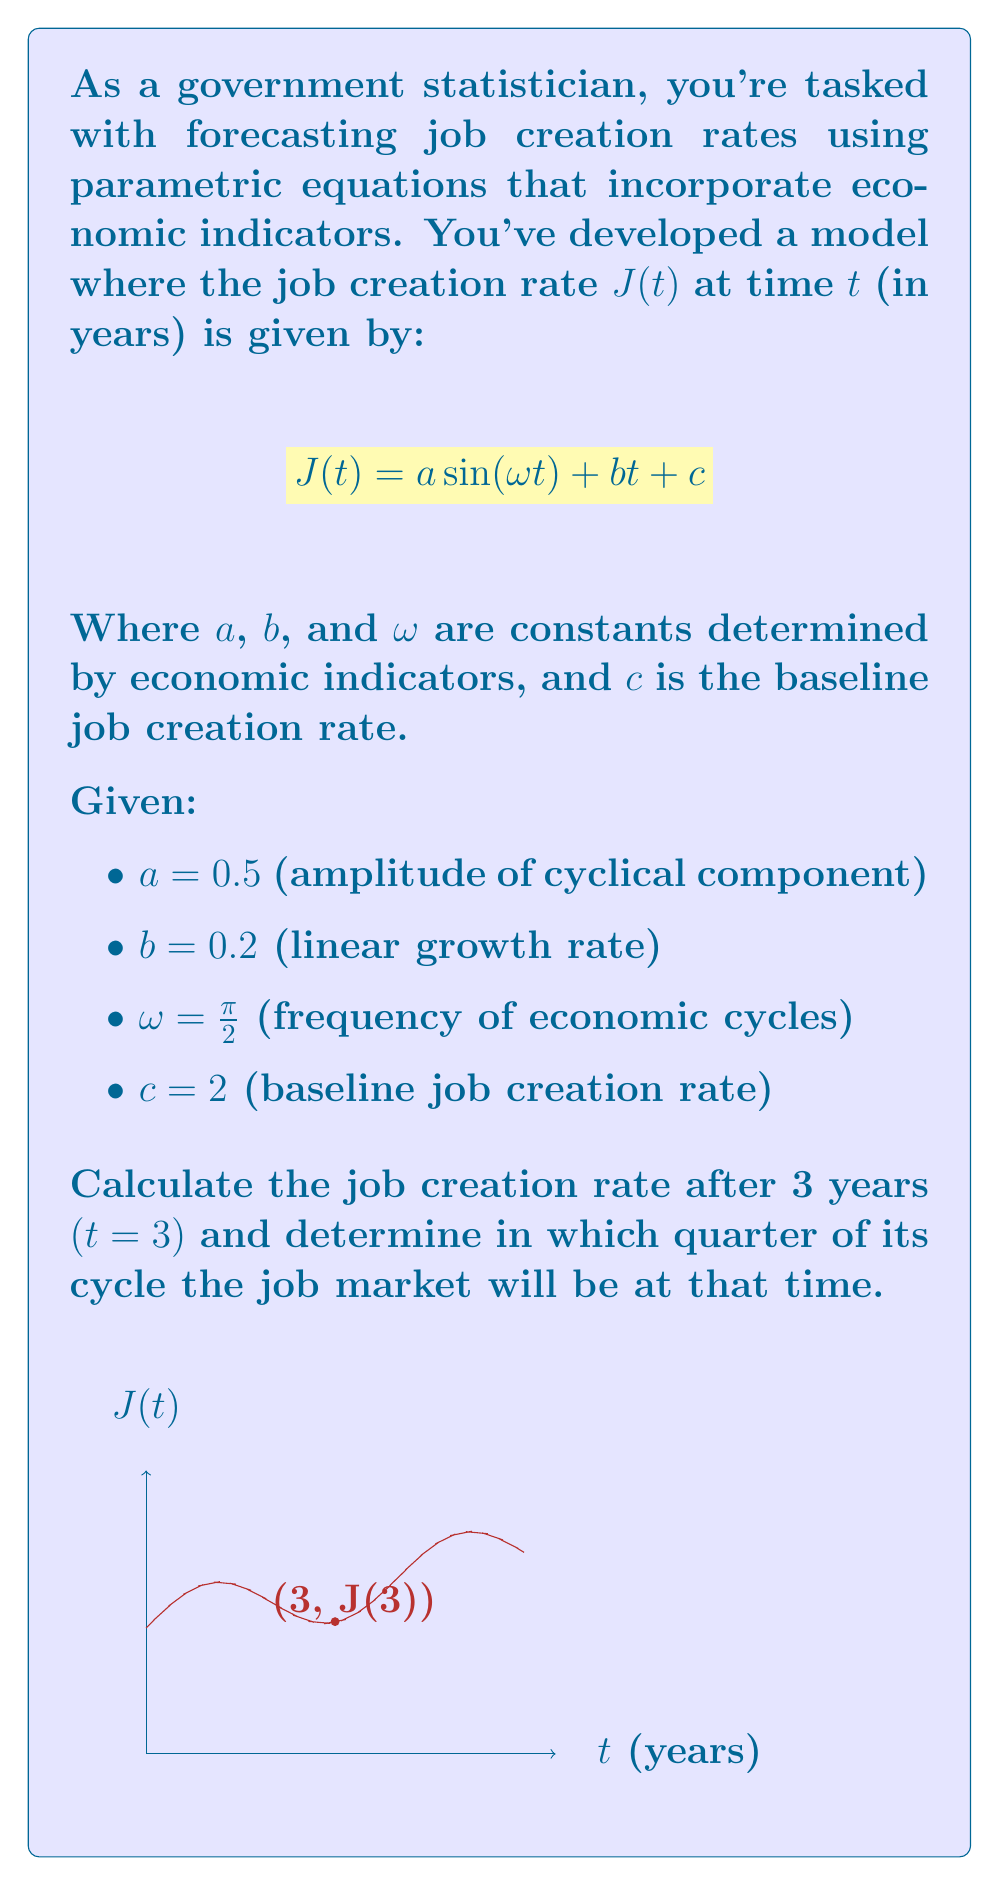Show me your answer to this math problem. Let's approach this step-by-step:

1) We're given the parametric equation for job creation rate:
   $$J(t) = a \sin(\omega t) + bt + c$$

2) Substituting the given values:
   $$J(t) = 0.5 \sin(\frac{\pi}{2} t) + 0.2t + 2$$

3) To find the job creation rate at $t=3$, we substitute $t=3$ into our equation:
   $$J(3) = 0.5 \sin(\frac{\pi}{2} \cdot 3) + 0.2 \cdot 3 + 2$$

4) Let's calculate each part:
   - $\sin(\frac{\pi}{2} \cdot 3) = \sin(\frac{3\pi}{2}) = -1$
   - $0.2 \cdot 3 = 0.6$

5) Now we can compute:
   $$J(3) = 0.5 \cdot (-1) + 0.6 + 2 = -0.5 + 0.6 + 2 = 2.1$$

6) To determine which quarter of the cycle the job market is in at $t=3$, we need to consider the sinusoidal part of the equation:
   $$0.5 \sin(\frac{\pi}{2} t)$$

7) At $t=3$, we have $\frac{\pi}{2} \cdot 3 = \frac{3\pi}{2}$, which corresponds to the 3rd quarter of the sine wave cycle (270°).
Answer: $J(3) = 2.1$; 3rd quarter of the cycle 